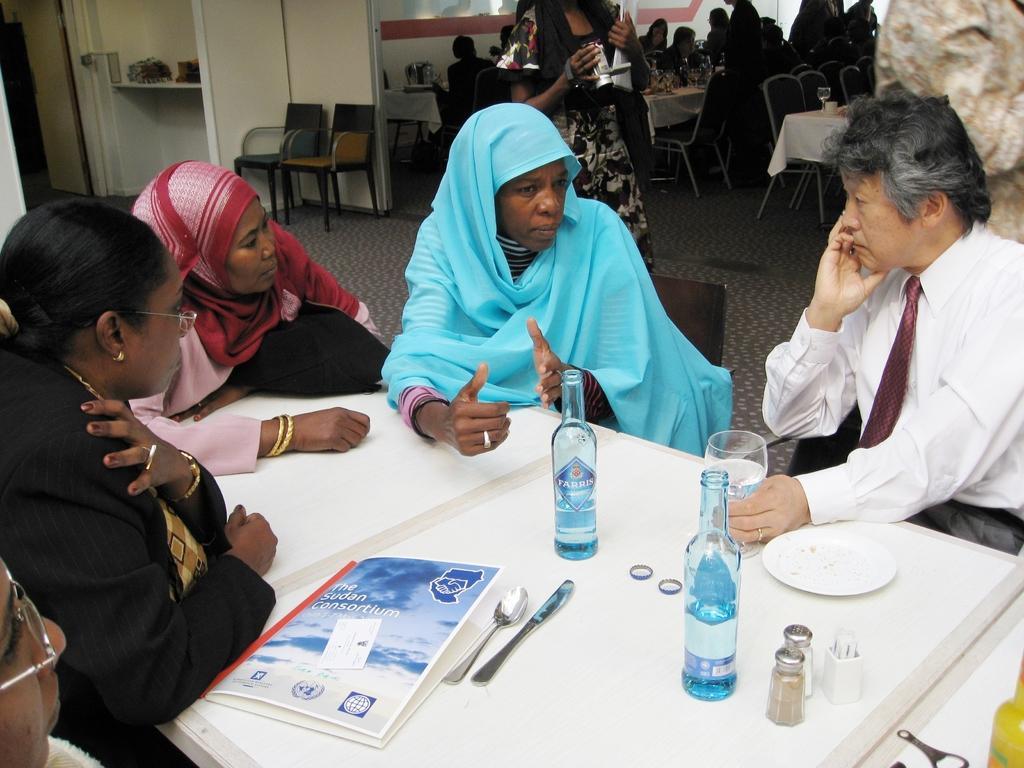How would you summarize this image in a sentence or two? In this image we can see persons sitting on the chairs and tables are placed in front of them. On the tables we can see sprinklers, books, cutlery, beverage bottles and bottle openers. In the background we can see chairs, walls and floor. 